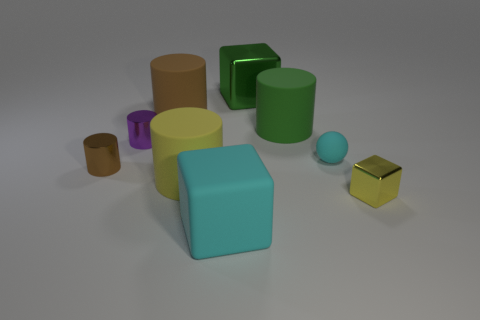How many brown cylinders must be subtracted to get 1 brown cylinders? 1 Subtract all tiny metal cubes. How many cubes are left? 2 Subtract 0 yellow balls. How many objects are left? 9 Subtract all spheres. How many objects are left? 8 Subtract 1 spheres. How many spheres are left? 0 Subtract all red cylinders. Subtract all cyan cubes. How many cylinders are left? 5 Subtract all yellow blocks. How many yellow cylinders are left? 1 Subtract all rubber balls. Subtract all small yellow blocks. How many objects are left? 7 Add 7 large yellow matte cylinders. How many large yellow matte cylinders are left? 8 Add 5 small objects. How many small objects exist? 9 